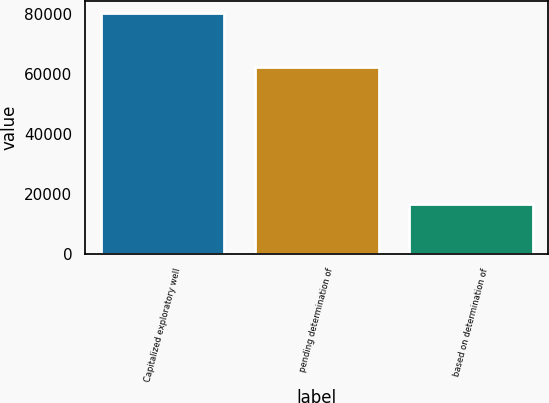Convert chart. <chart><loc_0><loc_0><loc_500><loc_500><bar_chart><fcel>Capitalized exploratory well<fcel>pending determination of<fcel>based on determination of<nl><fcel>80359<fcel>62580<fcel>16762<nl></chart> 